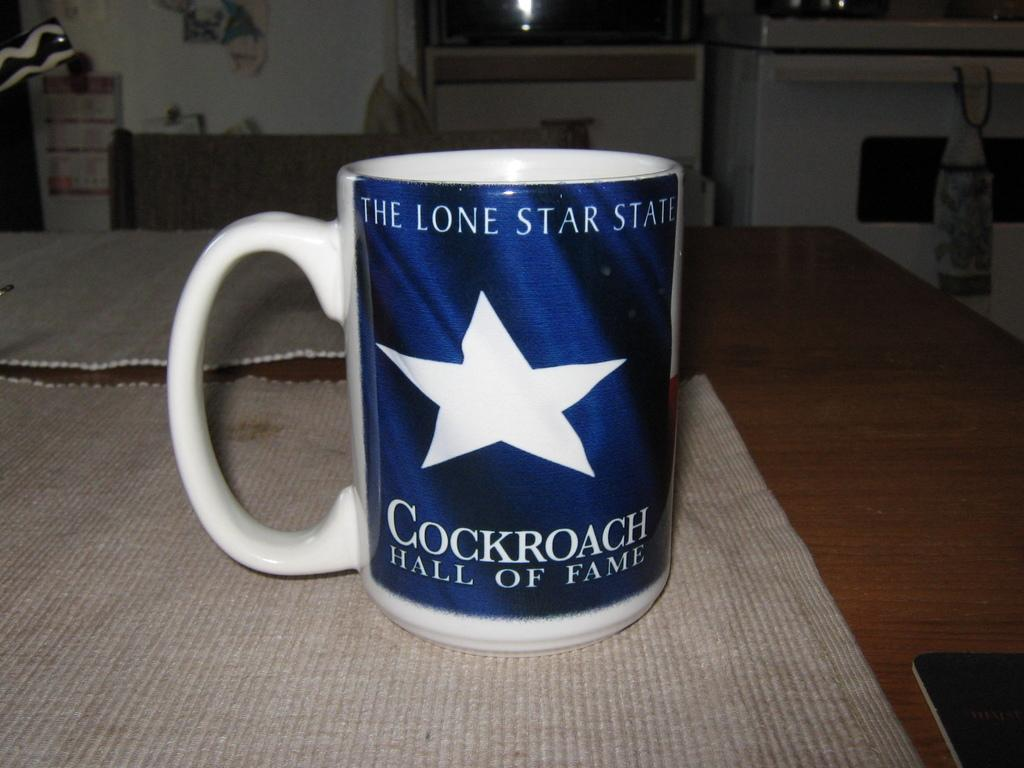What is the color of the mug in the image? The mug is blue and white in color. Where is the mug located in the image? The mug is on a table. What can be seen in the background of the image? In the background, there is a white wall, a washing machine, a stove, and a dishwasher. How many babies are sitting on the cushion in the image? There are no babies or cushions present in the image. 